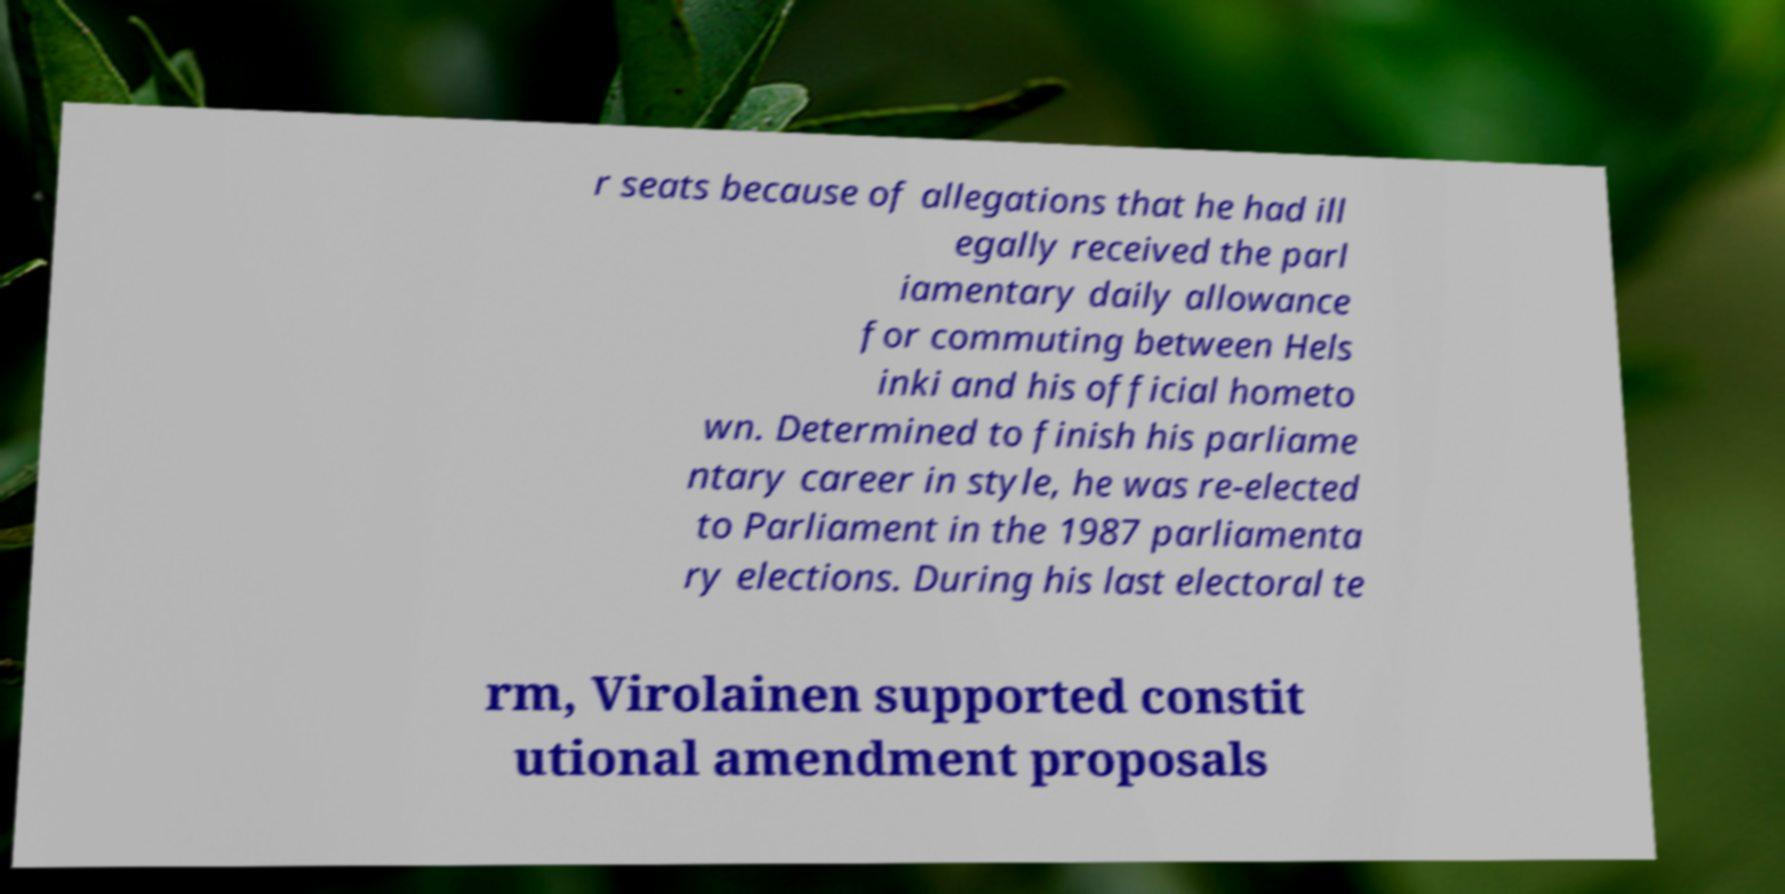Please identify and transcribe the text found in this image. r seats because of allegations that he had ill egally received the parl iamentary daily allowance for commuting between Hels inki and his official hometo wn. Determined to finish his parliame ntary career in style, he was re-elected to Parliament in the 1987 parliamenta ry elections. During his last electoral te rm, Virolainen supported constit utional amendment proposals 